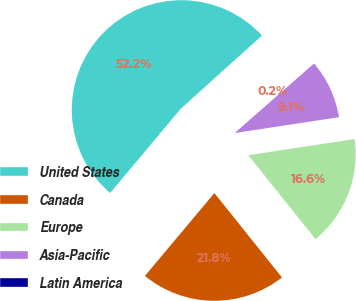Convert chart to OTSL. <chart><loc_0><loc_0><loc_500><loc_500><pie_chart><fcel>United States<fcel>Canada<fcel>Europe<fcel>Asia-Pacific<fcel>Latin America<nl><fcel>52.22%<fcel>21.85%<fcel>16.65%<fcel>9.06%<fcel>0.23%<nl></chart> 